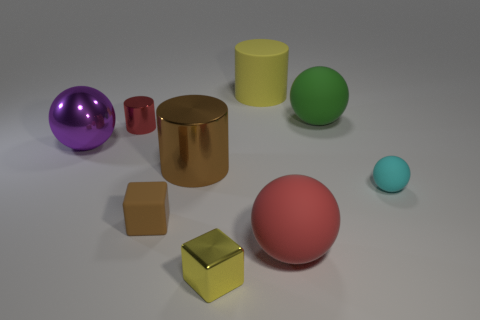Add 1 big cyan rubber cylinders. How many objects exist? 10 Subtract all brown cylinders. How many cylinders are left? 2 Subtract all cyan matte balls. How many balls are left? 3 Subtract 0 red blocks. How many objects are left? 9 Subtract all balls. How many objects are left? 5 Subtract 1 blocks. How many blocks are left? 1 Subtract all cyan spheres. Subtract all red cylinders. How many spheres are left? 3 Subtract all red cylinders. How many red cubes are left? 0 Subtract all large purple rubber cylinders. Subtract all red metal things. How many objects are left? 8 Add 8 yellow rubber cylinders. How many yellow rubber cylinders are left? 9 